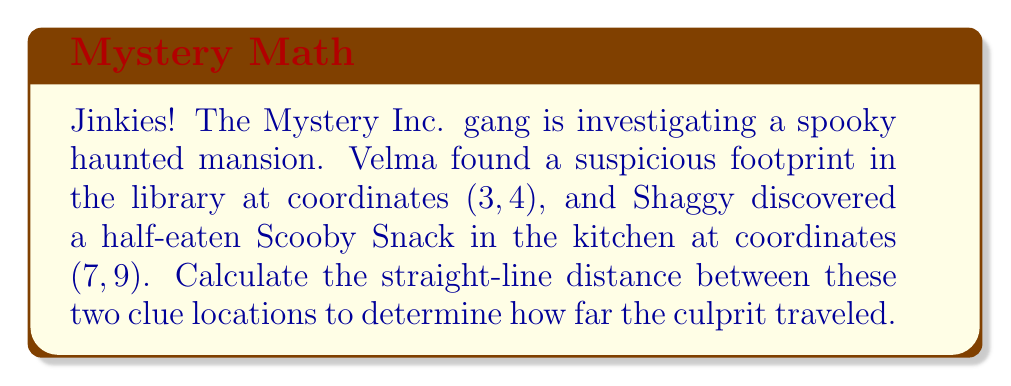Give your solution to this math problem. Let's solve this mystery step by step, gang!

1) We can use the distance formula to calculate the straight-line distance between two points. The distance formula is derived from the Pythagorean theorem:

   $$d = \sqrt{(x_2 - x_1)^2 + (y_2 - y_1)^2}$$

   Where $(x_1, y_1)$ is the first point and $(x_2, y_2)$ is the second point.

2) In our case:
   - The library (footprint) is at (3, 4): $(x_1, y_1) = (3, 4)$
   - The kitchen (Scooby Snack) is at (7, 9): $(x_2, y_2) = (7, 9)$

3) Let's plug these values into our formula:

   $$d = \sqrt{(7 - 3)^2 + (9 - 4)^2}$$

4) Simplify the expressions inside the parentheses:

   $$d = \sqrt{4^2 + 5^2}$$

5) Calculate the squares:

   $$d = \sqrt{16 + 25}$$

6) Add under the square root:

   $$d = \sqrt{41}$$

7) This is our final answer, but we can approximate it:

   $$d \approx 6.40$$

So, the culprit traveled approximately 6.40 units between the two clue locations.

[asy]
unitsize(30);
draw((-1,-1)--(8,10), gray);
dot((3,4));
dot((7,9));
label("Library (3,4)", (3,4), SW);
label("Kitchen (7,9)", (7,9), NE);
draw((3,4)--(7,4)--(7,9), dashed);
label("4", (5,4), S);
label("5", (7,6.5), E);
[/asy]
Answer: The distance between the two clue locations is $\sqrt{41}$ units, or approximately 6.40 units. 